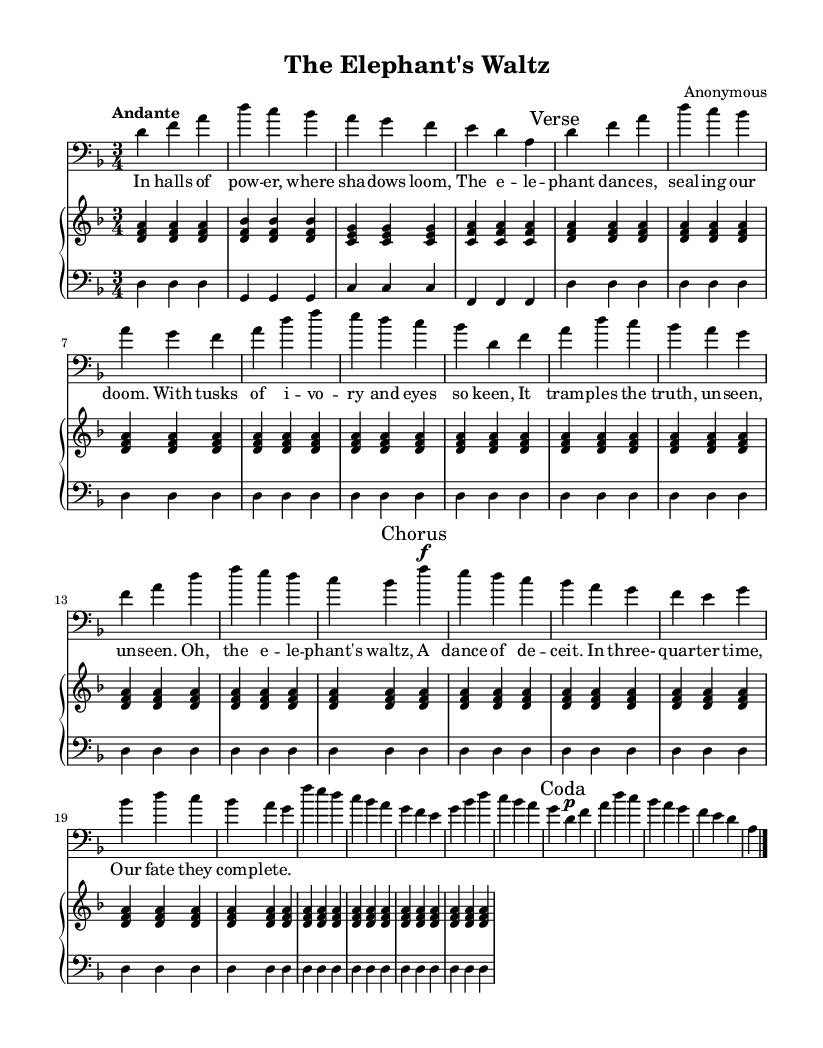What is the key signature of this music? The key signature is indicated at the beginning of the score, showing two flats (B♭ and E♭), which is characteristic of D minor.
Answer: D minor What is the time signature of this music? The time signature is found at the beginning of the sheet music and is written as 3/4, indicating three beats per measure.
Answer: 3/4 What is the tempo marking for this piece? The tempo marking is located at the start of the score, reading "Andante," which indicates a moderate pace.
Answer: Andante How many verses are included in the piece? The lyrics section includes "Verse 1" which indicates that there is one verse prepared for performance. There is also no indication of additional verses, so we conclude one is present.
Answer: 1 Which voice clef is used in the vocal part? The vocal part is clearly marked at the beginning with a "bass" clef, which is used to notate lower vocal ranges.
Answer: Bass What is the primary theme of the lyrics? The lyrics depict a theme of political intrigue, focusing on power and deception, specifically symbolized by the figurative "elephant" representing authority.
Answer: Political intrigue 